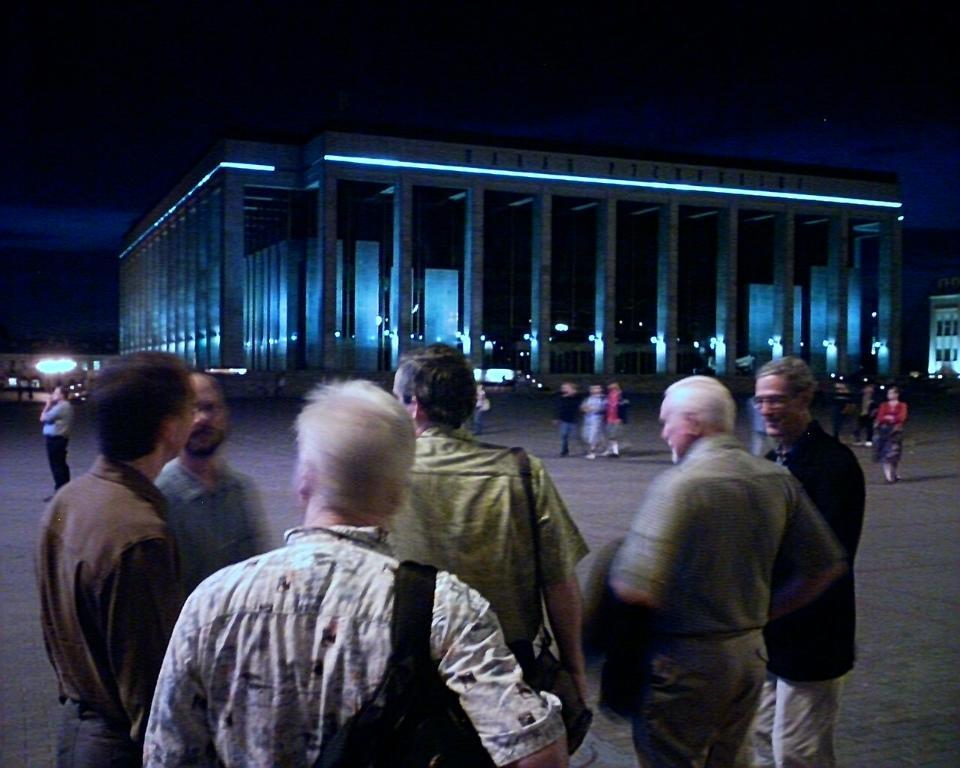What are the people in the image doing? There are people standing and walking in the image. What can be seen in the background of the image? There are buildings visible in the image. What are the men wearing in the image? There are men wearing bags in the image. What is the man holding in his hand? There is a man holding a coat in his hand. What type of knowledge is being transferred through the gate in the image? There is no gate present in the image, and therefore no knowledge transfer can be observed. 